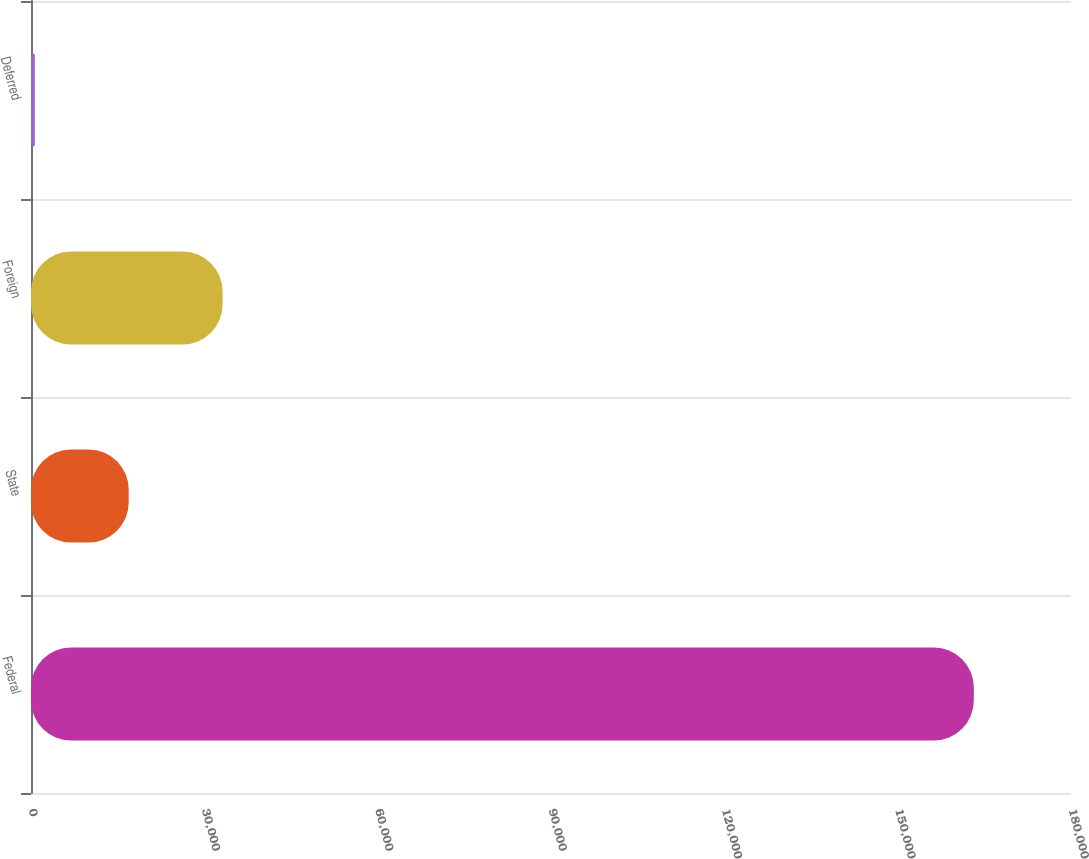Convert chart to OTSL. <chart><loc_0><loc_0><loc_500><loc_500><bar_chart><fcel>Federal<fcel>State<fcel>Foreign<fcel>Deferred<nl><fcel>163182<fcel>16912.2<fcel>33164.4<fcel>660<nl></chart> 